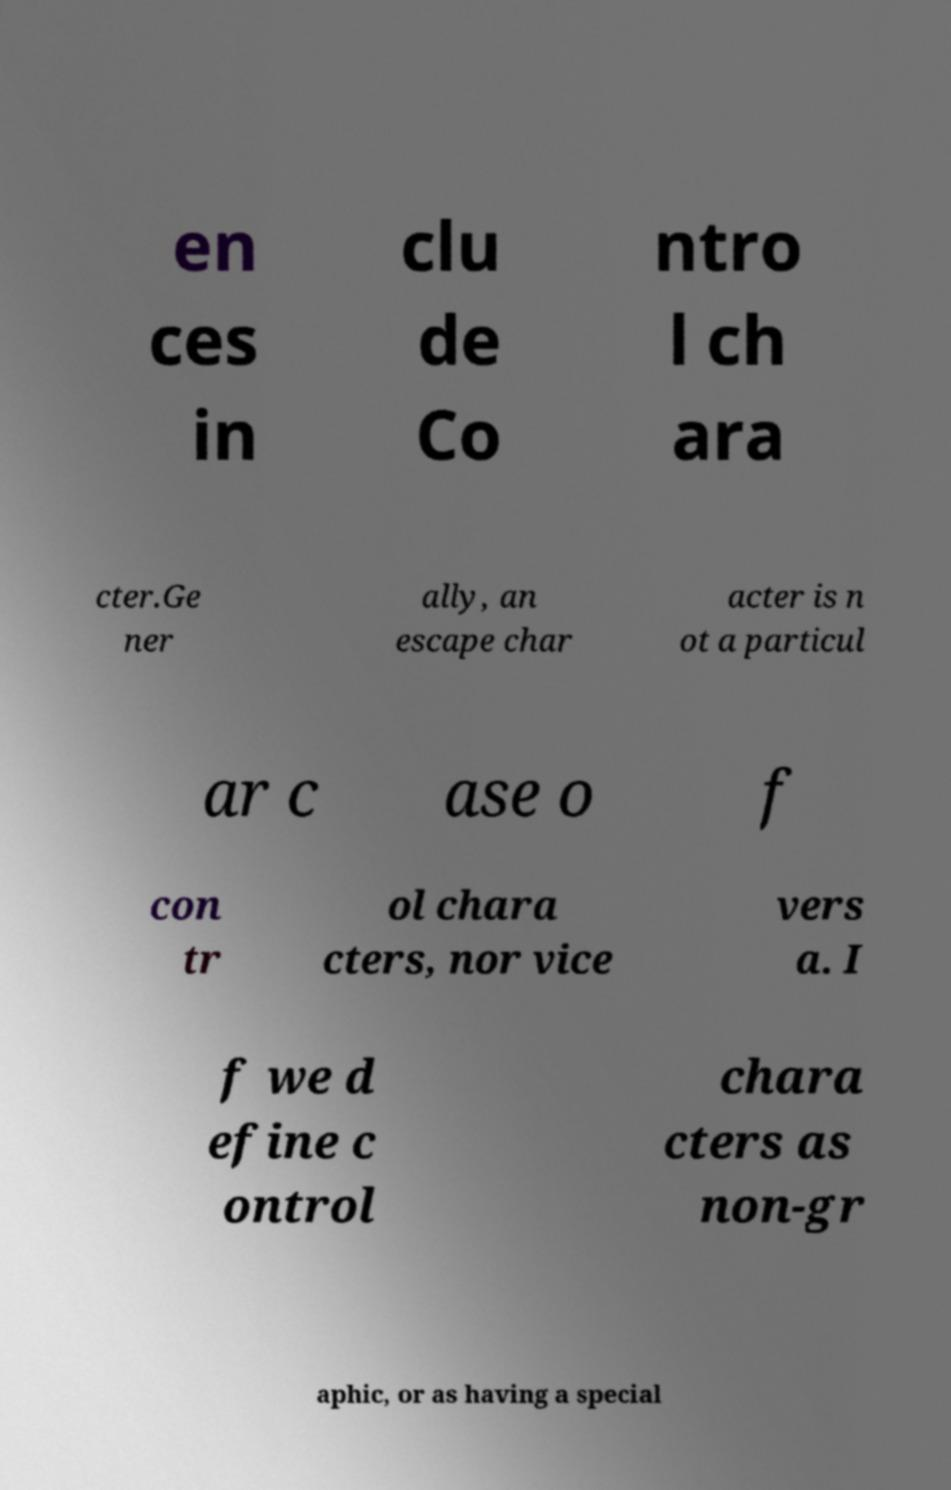Could you assist in decoding the text presented in this image and type it out clearly? en ces in clu de Co ntro l ch ara cter.Ge ner ally, an escape char acter is n ot a particul ar c ase o f con tr ol chara cters, nor vice vers a. I f we d efine c ontrol chara cters as non-gr aphic, or as having a special 